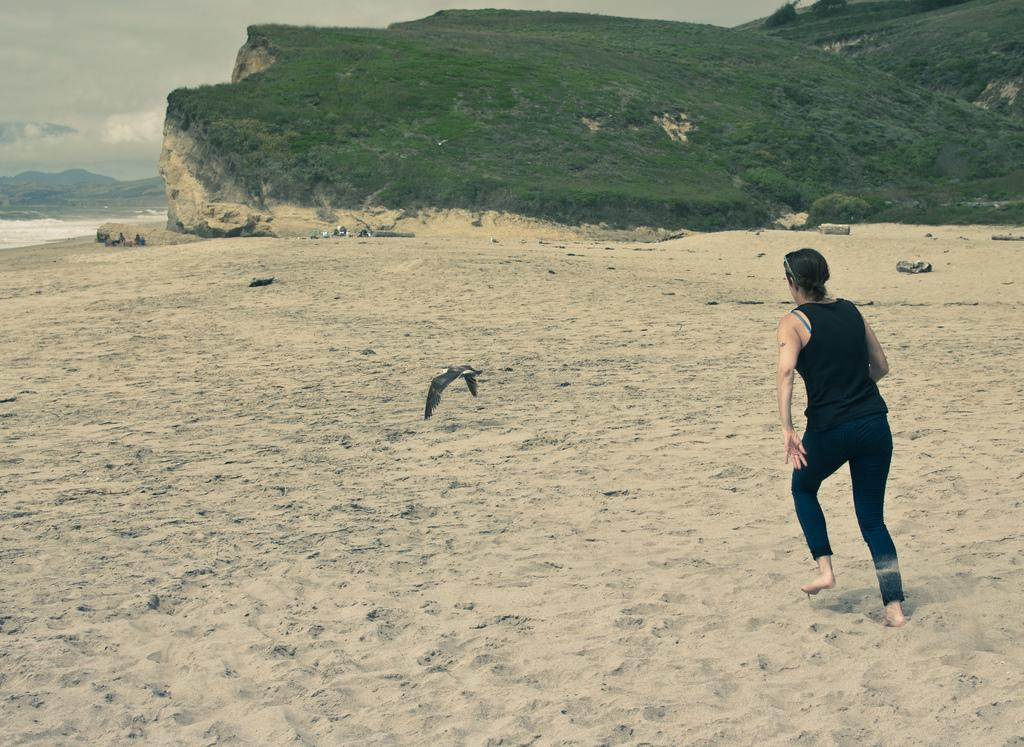Who is present in the image? There is a woman in the image. What is the woman wearing? The woman is wearing a black dress. What is the woman doing in the image? The woman is running on the beach. What else can be seen in the image besides the woman? There is a bird flying in the image, and there is a hill with grass in the background. What can be seen above the hill in the background? The sky is visible above the hill. What type of food is the woman holding in the image? There is no food visible in the image; the woman is running on the beach. 